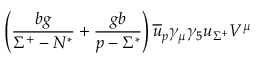Convert formula to latex. <formula><loc_0><loc_0><loc_500><loc_500>\left ( \frac { b g } { \Sigma ^ { + } - N ^ { * } } + \frac { g b } { p - \Sigma ^ { * } } \right ) \overline { u } _ { p } \gamma _ { \mu } \gamma _ { 5 } u _ { \Sigma ^ { + } } V ^ { \mu }</formula> 